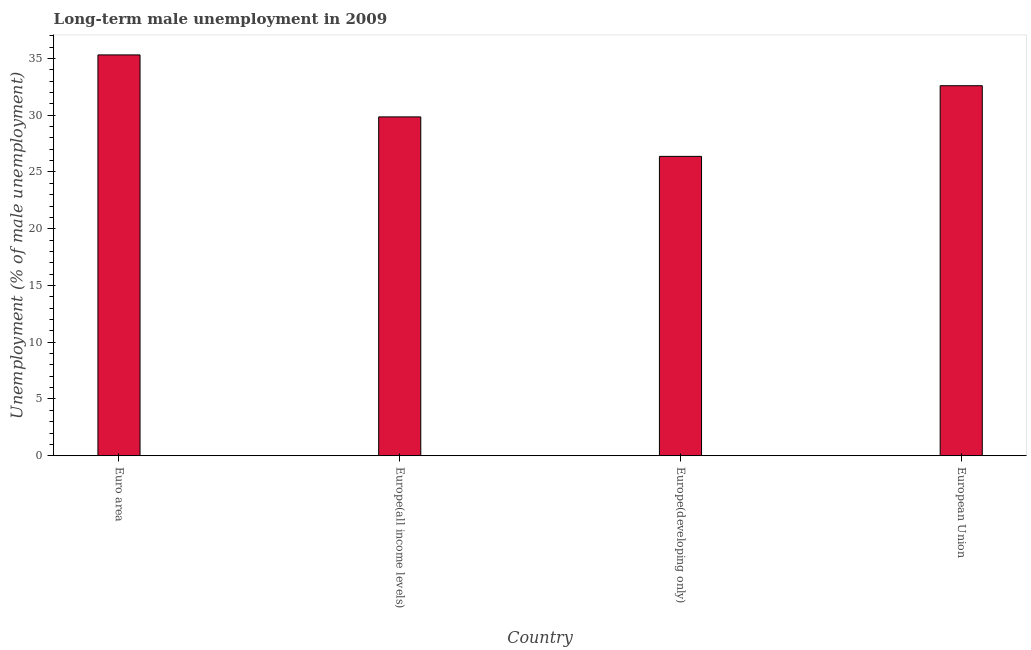Does the graph contain grids?
Your response must be concise. No. What is the title of the graph?
Ensure brevity in your answer.  Long-term male unemployment in 2009. What is the label or title of the X-axis?
Give a very brief answer. Country. What is the label or title of the Y-axis?
Give a very brief answer. Unemployment (% of male unemployment). What is the long-term male unemployment in Europe(developing only)?
Offer a terse response. 26.38. Across all countries, what is the maximum long-term male unemployment?
Make the answer very short. 35.32. Across all countries, what is the minimum long-term male unemployment?
Offer a terse response. 26.38. In which country was the long-term male unemployment minimum?
Your answer should be very brief. Europe(developing only). What is the sum of the long-term male unemployment?
Your response must be concise. 124.15. What is the difference between the long-term male unemployment in Europe(developing only) and European Union?
Make the answer very short. -6.23. What is the average long-term male unemployment per country?
Provide a succinct answer. 31.04. What is the median long-term male unemployment?
Provide a short and direct response. 31.23. In how many countries, is the long-term male unemployment greater than 9 %?
Provide a short and direct response. 4. What is the ratio of the long-term male unemployment in Euro area to that in Europe(developing only)?
Your response must be concise. 1.34. Is the long-term male unemployment in Euro area less than that in European Union?
Offer a very short reply. No. Is the difference between the long-term male unemployment in Euro area and European Union greater than the difference between any two countries?
Provide a short and direct response. No. What is the difference between the highest and the second highest long-term male unemployment?
Provide a succinct answer. 2.71. What is the difference between the highest and the lowest long-term male unemployment?
Your answer should be compact. 8.94. In how many countries, is the long-term male unemployment greater than the average long-term male unemployment taken over all countries?
Your answer should be compact. 2. How many bars are there?
Provide a succinct answer. 4. How many countries are there in the graph?
Make the answer very short. 4. What is the Unemployment (% of male unemployment) of Euro area?
Provide a succinct answer. 35.32. What is the Unemployment (% of male unemployment) of Europe(all income levels)?
Keep it short and to the point. 29.85. What is the Unemployment (% of male unemployment) in Europe(developing only)?
Your response must be concise. 26.38. What is the Unemployment (% of male unemployment) of European Union?
Your response must be concise. 32.6. What is the difference between the Unemployment (% of male unemployment) in Euro area and Europe(all income levels)?
Your answer should be very brief. 5.46. What is the difference between the Unemployment (% of male unemployment) in Euro area and Europe(developing only)?
Ensure brevity in your answer.  8.94. What is the difference between the Unemployment (% of male unemployment) in Euro area and European Union?
Your response must be concise. 2.71. What is the difference between the Unemployment (% of male unemployment) in Europe(all income levels) and Europe(developing only)?
Make the answer very short. 3.48. What is the difference between the Unemployment (% of male unemployment) in Europe(all income levels) and European Union?
Offer a terse response. -2.75. What is the difference between the Unemployment (% of male unemployment) in Europe(developing only) and European Union?
Your answer should be compact. -6.23. What is the ratio of the Unemployment (% of male unemployment) in Euro area to that in Europe(all income levels)?
Provide a succinct answer. 1.18. What is the ratio of the Unemployment (% of male unemployment) in Euro area to that in Europe(developing only)?
Your answer should be very brief. 1.34. What is the ratio of the Unemployment (% of male unemployment) in Euro area to that in European Union?
Offer a terse response. 1.08. What is the ratio of the Unemployment (% of male unemployment) in Europe(all income levels) to that in Europe(developing only)?
Give a very brief answer. 1.13. What is the ratio of the Unemployment (% of male unemployment) in Europe(all income levels) to that in European Union?
Offer a very short reply. 0.92. What is the ratio of the Unemployment (% of male unemployment) in Europe(developing only) to that in European Union?
Make the answer very short. 0.81. 